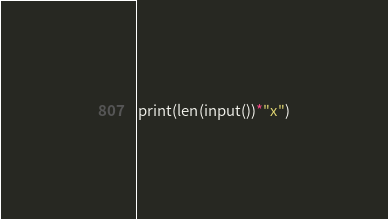<code> <loc_0><loc_0><loc_500><loc_500><_Python_>print(len(input())*"x")</code> 